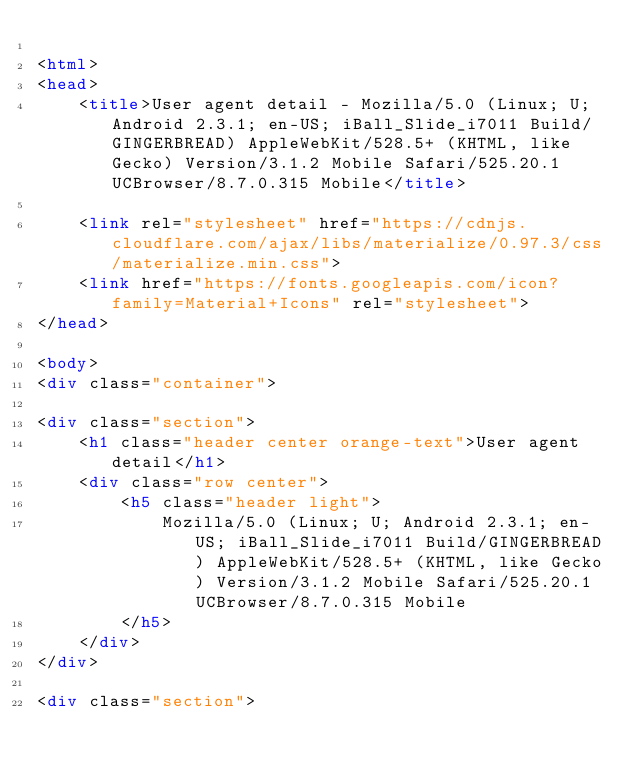Convert code to text. <code><loc_0><loc_0><loc_500><loc_500><_HTML_>
<html>
<head>
    <title>User agent detail - Mozilla/5.0 (Linux; U; Android 2.3.1; en-US; iBall_Slide_i7011 Build/GINGERBREAD) AppleWebKit/528.5+ (KHTML, like Gecko) Version/3.1.2 Mobile Safari/525.20.1 UCBrowser/8.7.0.315 Mobile</title>
        
    <link rel="stylesheet" href="https://cdnjs.cloudflare.com/ajax/libs/materialize/0.97.3/css/materialize.min.css">
    <link href="https://fonts.googleapis.com/icon?family=Material+Icons" rel="stylesheet">
</head>
        
<body>
<div class="container">
    
<div class="section">
	<h1 class="header center orange-text">User agent detail</h1>
	<div class="row center">
        <h5 class="header light">
            Mozilla/5.0 (Linux; U; Android 2.3.1; en-US; iBall_Slide_i7011 Build/GINGERBREAD) AppleWebKit/528.5+ (KHTML, like Gecko) Version/3.1.2 Mobile Safari/525.20.1 UCBrowser/8.7.0.315 Mobile
        </h5>
	</div>
</div>   

<div class="section"></code> 